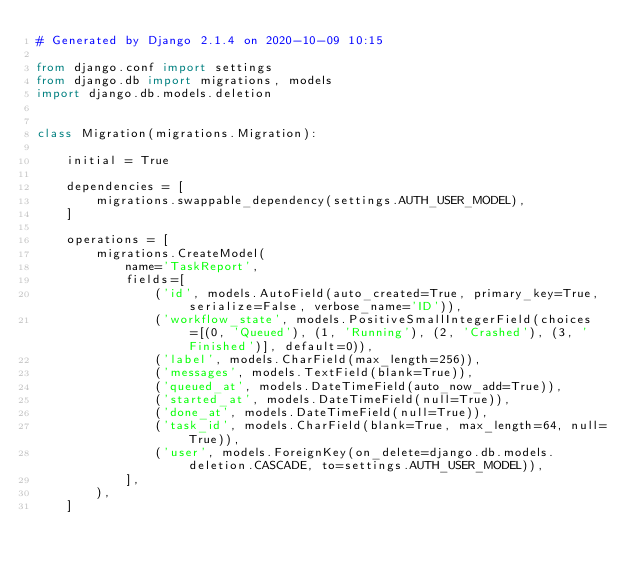Convert code to text. <code><loc_0><loc_0><loc_500><loc_500><_Python_># Generated by Django 2.1.4 on 2020-10-09 10:15

from django.conf import settings
from django.db import migrations, models
import django.db.models.deletion


class Migration(migrations.Migration):

    initial = True

    dependencies = [
        migrations.swappable_dependency(settings.AUTH_USER_MODEL),
    ]

    operations = [
        migrations.CreateModel(
            name='TaskReport',
            fields=[
                ('id', models.AutoField(auto_created=True, primary_key=True, serialize=False, verbose_name='ID')),
                ('workflow_state', models.PositiveSmallIntegerField(choices=[(0, 'Queued'), (1, 'Running'), (2, 'Crashed'), (3, 'Finished')], default=0)),
                ('label', models.CharField(max_length=256)),
                ('messages', models.TextField(blank=True)),
                ('queued_at', models.DateTimeField(auto_now_add=True)),
                ('started_at', models.DateTimeField(null=True)),
                ('done_at', models.DateTimeField(null=True)),
                ('task_id', models.CharField(blank=True, max_length=64, null=True)),
                ('user', models.ForeignKey(on_delete=django.db.models.deletion.CASCADE, to=settings.AUTH_USER_MODEL)),
            ],
        ),
    ]
</code> 